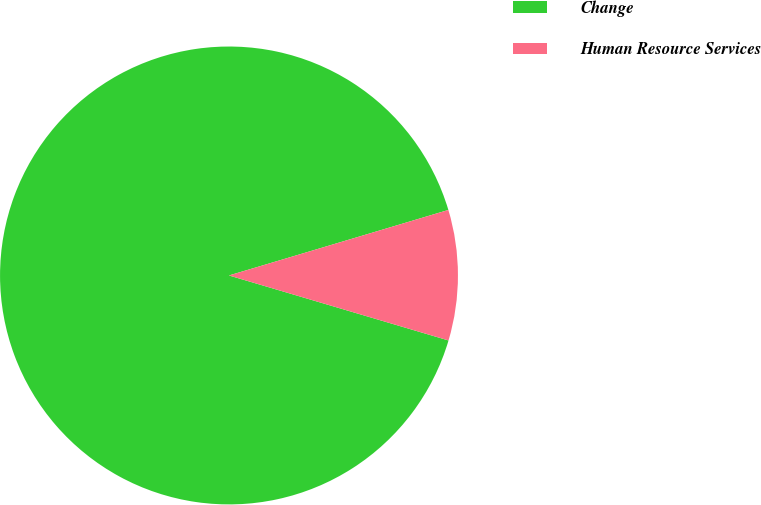<chart> <loc_0><loc_0><loc_500><loc_500><pie_chart><fcel>Change<fcel>Human Resource Services<nl><fcel>90.8%<fcel>9.2%<nl></chart> 